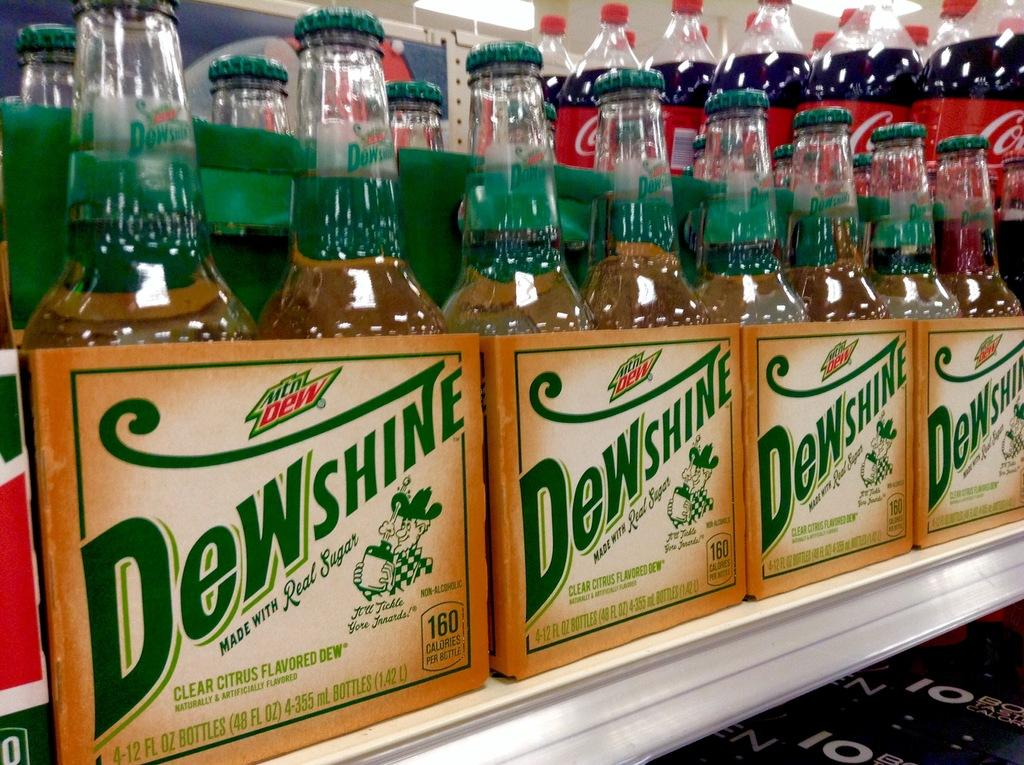<image>
Create a compact narrative representing the image presented. Several bottles of a beverage called Dewshine sitting on a shelf. 